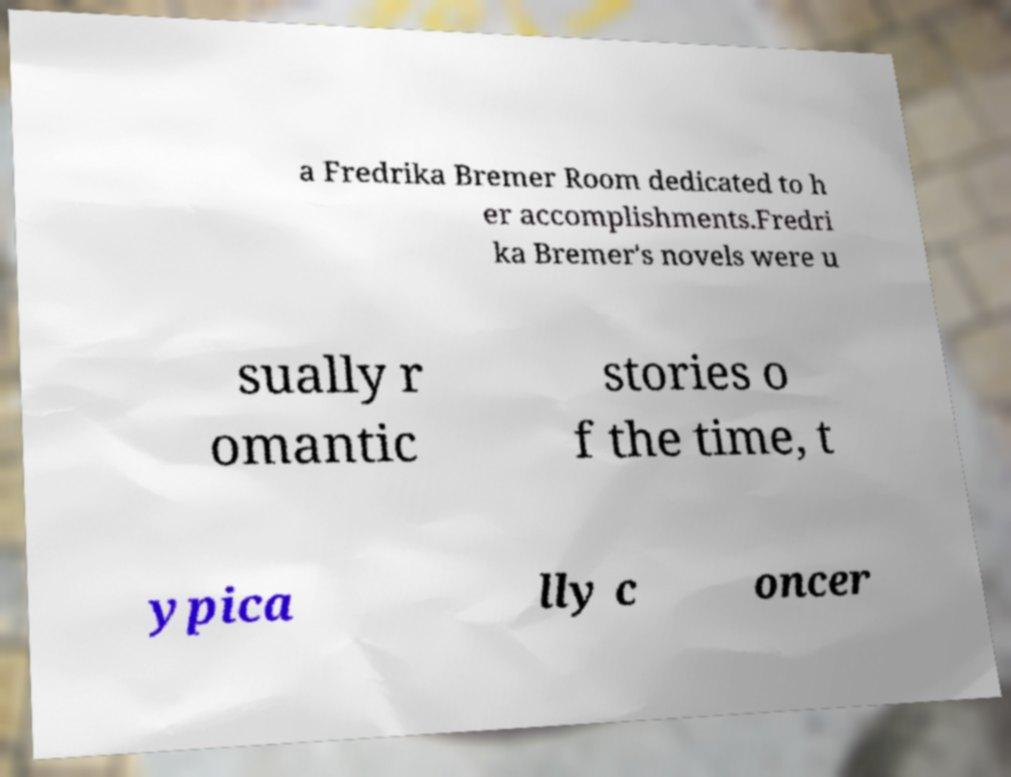For documentation purposes, I need the text within this image transcribed. Could you provide that? a Fredrika Bremer Room dedicated to h er accomplishments.Fredri ka Bremer's novels were u sually r omantic stories o f the time, t ypica lly c oncer 